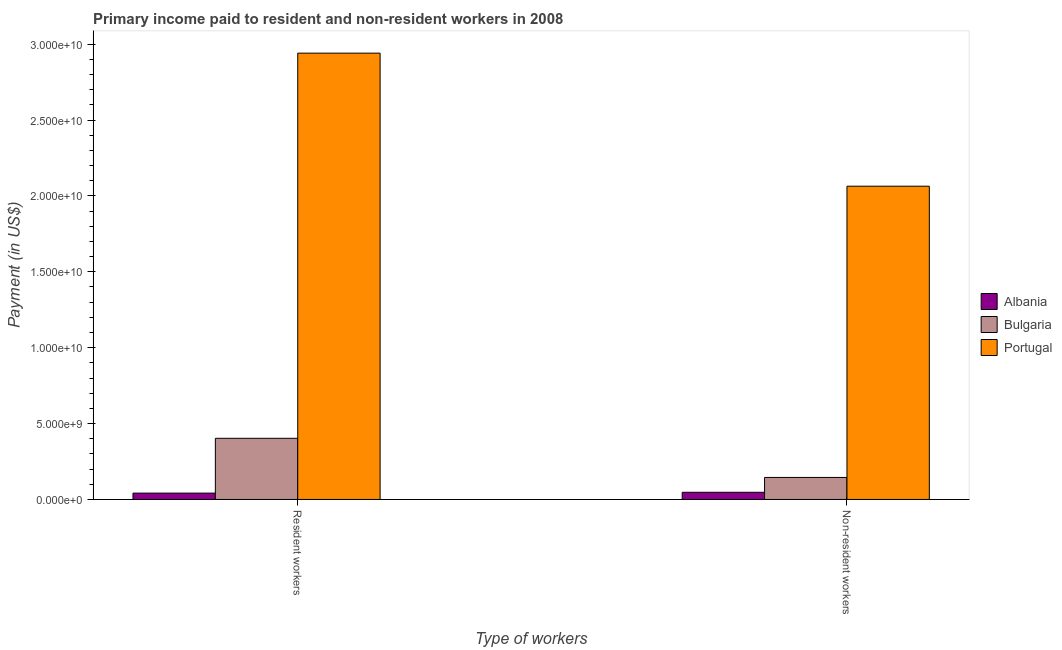How many groups of bars are there?
Give a very brief answer. 2. Are the number of bars per tick equal to the number of legend labels?
Your answer should be very brief. Yes. How many bars are there on the 2nd tick from the left?
Your answer should be very brief. 3. What is the label of the 2nd group of bars from the left?
Make the answer very short. Non-resident workers. What is the payment made to resident workers in Portugal?
Your answer should be very brief. 2.94e+1. Across all countries, what is the maximum payment made to non-resident workers?
Provide a short and direct response. 2.06e+1. Across all countries, what is the minimum payment made to non-resident workers?
Ensure brevity in your answer.  4.73e+08. In which country was the payment made to non-resident workers minimum?
Your answer should be compact. Albania. What is the total payment made to non-resident workers in the graph?
Your response must be concise. 2.26e+1. What is the difference between the payment made to resident workers in Portugal and that in Bulgaria?
Keep it short and to the point. 2.54e+1. What is the difference between the payment made to resident workers in Bulgaria and the payment made to non-resident workers in Portugal?
Make the answer very short. -1.66e+1. What is the average payment made to non-resident workers per country?
Keep it short and to the point. 7.52e+09. What is the difference between the payment made to non-resident workers and payment made to resident workers in Bulgaria?
Your response must be concise. -2.58e+09. In how many countries, is the payment made to non-resident workers greater than 1000000000 US$?
Your response must be concise. 2. What is the ratio of the payment made to non-resident workers in Albania to that in Portugal?
Provide a short and direct response. 0.02. Is the payment made to resident workers in Bulgaria less than that in Albania?
Your answer should be very brief. No. What does the 1st bar from the left in Non-resident workers represents?
Your answer should be very brief. Albania. How many bars are there?
Provide a short and direct response. 6. Are all the bars in the graph horizontal?
Your response must be concise. No. How many countries are there in the graph?
Your response must be concise. 3. What is the difference between two consecutive major ticks on the Y-axis?
Provide a short and direct response. 5.00e+09. Are the values on the major ticks of Y-axis written in scientific E-notation?
Your response must be concise. Yes. Does the graph contain any zero values?
Offer a very short reply. No. Does the graph contain grids?
Provide a succinct answer. No. How many legend labels are there?
Your answer should be compact. 3. What is the title of the graph?
Your answer should be compact. Primary income paid to resident and non-resident workers in 2008. Does "Zambia" appear as one of the legend labels in the graph?
Your answer should be compact. No. What is the label or title of the X-axis?
Offer a very short reply. Type of workers. What is the label or title of the Y-axis?
Your answer should be very brief. Payment (in US$). What is the Payment (in US$) of Albania in Resident workers?
Offer a very short reply. 4.18e+08. What is the Payment (in US$) of Bulgaria in Resident workers?
Offer a very short reply. 4.03e+09. What is the Payment (in US$) in Portugal in Resident workers?
Provide a short and direct response. 2.94e+1. What is the Payment (in US$) in Albania in Non-resident workers?
Offer a very short reply. 4.73e+08. What is the Payment (in US$) in Bulgaria in Non-resident workers?
Your answer should be very brief. 1.45e+09. What is the Payment (in US$) of Portugal in Non-resident workers?
Your answer should be very brief. 2.06e+1. Across all Type of workers, what is the maximum Payment (in US$) in Albania?
Your answer should be very brief. 4.73e+08. Across all Type of workers, what is the maximum Payment (in US$) in Bulgaria?
Offer a terse response. 4.03e+09. Across all Type of workers, what is the maximum Payment (in US$) of Portugal?
Your answer should be very brief. 2.94e+1. Across all Type of workers, what is the minimum Payment (in US$) in Albania?
Your response must be concise. 4.18e+08. Across all Type of workers, what is the minimum Payment (in US$) in Bulgaria?
Make the answer very short. 1.45e+09. Across all Type of workers, what is the minimum Payment (in US$) in Portugal?
Your answer should be compact. 2.06e+1. What is the total Payment (in US$) in Albania in the graph?
Ensure brevity in your answer.  8.91e+08. What is the total Payment (in US$) in Bulgaria in the graph?
Offer a very short reply. 5.48e+09. What is the total Payment (in US$) of Portugal in the graph?
Your response must be concise. 5.00e+1. What is the difference between the Payment (in US$) in Albania in Resident workers and that in Non-resident workers?
Make the answer very short. -5.48e+07. What is the difference between the Payment (in US$) of Bulgaria in Resident workers and that in Non-resident workers?
Offer a very short reply. 2.58e+09. What is the difference between the Payment (in US$) in Portugal in Resident workers and that in Non-resident workers?
Offer a terse response. 8.77e+09. What is the difference between the Payment (in US$) of Albania in Resident workers and the Payment (in US$) of Bulgaria in Non-resident workers?
Provide a succinct answer. -1.03e+09. What is the difference between the Payment (in US$) in Albania in Resident workers and the Payment (in US$) in Portugal in Non-resident workers?
Give a very brief answer. -2.02e+1. What is the difference between the Payment (in US$) in Bulgaria in Resident workers and the Payment (in US$) in Portugal in Non-resident workers?
Your answer should be compact. -1.66e+1. What is the average Payment (in US$) in Albania per Type of workers?
Offer a very short reply. 4.46e+08. What is the average Payment (in US$) of Bulgaria per Type of workers?
Your answer should be compact. 2.74e+09. What is the average Payment (in US$) of Portugal per Type of workers?
Your response must be concise. 2.50e+1. What is the difference between the Payment (in US$) in Albania and Payment (in US$) in Bulgaria in Resident workers?
Ensure brevity in your answer.  -3.61e+09. What is the difference between the Payment (in US$) in Albania and Payment (in US$) in Portugal in Resident workers?
Provide a succinct answer. -2.90e+1. What is the difference between the Payment (in US$) in Bulgaria and Payment (in US$) in Portugal in Resident workers?
Your answer should be compact. -2.54e+1. What is the difference between the Payment (in US$) in Albania and Payment (in US$) in Bulgaria in Non-resident workers?
Your response must be concise. -9.78e+08. What is the difference between the Payment (in US$) in Albania and Payment (in US$) in Portugal in Non-resident workers?
Your answer should be very brief. -2.02e+1. What is the difference between the Payment (in US$) of Bulgaria and Payment (in US$) of Portugal in Non-resident workers?
Offer a very short reply. -1.92e+1. What is the ratio of the Payment (in US$) of Albania in Resident workers to that in Non-resident workers?
Offer a very short reply. 0.88. What is the ratio of the Payment (in US$) of Bulgaria in Resident workers to that in Non-resident workers?
Your response must be concise. 2.78. What is the ratio of the Payment (in US$) in Portugal in Resident workers to that in Non-resident workers?
Your response must be concise. 1.42. What is the difference between the highest and the second highest Payment (in US$) in Albania?
Offer a very short reply. 5.48e+07. What is the difference between the highest and the second highest Payment (in US$) of Bulgaria?
Offer a very short reply. 2.58e+09. What is the difference between the highest and the second highest Payment (in US$) of Portugal?
Provide a succinct answer. 8.77e+09. What is the difference between the highest and the lowest Payment (in US$) in Albania?
Keep it short and to the point. 5.48e+07. What is the difference between the highest and the lowest Payment (in US$) of Bulgaria?
Make the answer very short. 2.58e+09. What is the difference between the highest and the lowest Payment (in US$) in Portugal?
Offer a terse response. 8.77e+09. 